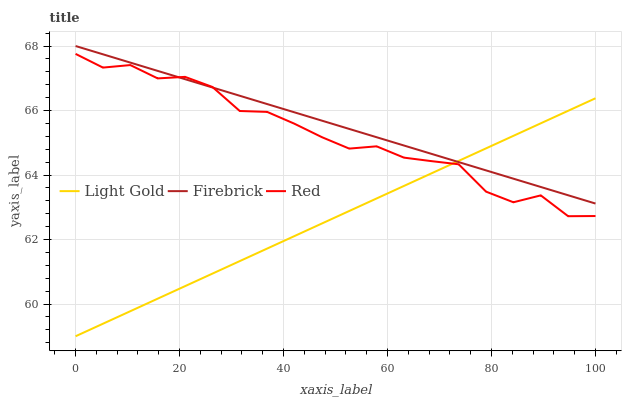Does Light Gold have the minimum area under the curve?
Answer yes or no. Yes. Does Firebrick have the maximum area under the curve?
Answer yes or no. Yes. Does Red have the minimum area under the curve?
Answer yes or no. No. Does Red have the maximum area under the curve?
Answer yes or no. No. Is Light Gold the smoothest?
Answer yes or no. Yes. Is Red the roughest?
Answer yes or no. Yes. Is Red the smoothest?
Answer yes or no. No. Is Light Gold the roughest?
Answer yes or no. No. Does Light Gold have the lowest value?
Answer yes or no. Yes. Does Red have the lowest value?
Answer yes or no. No. Does Firebrick have the highest value?
Answer yes or no. Yes. Does Red have the highest value?
Answer yes or no. No. Does Red intersect Firebrick?
Answer yes or no. Yes. Is Red less than Firebrick?
Answer yes or no. No. Is Red greater than Firebrick?
Answer yes or no. No. 